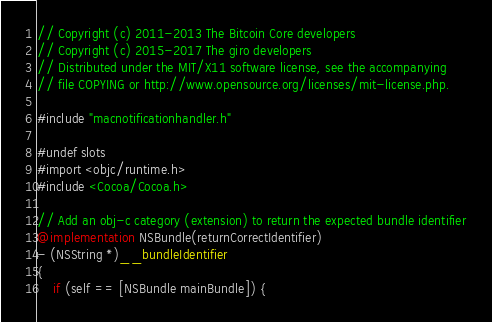Convert code to text. <code><loc_0><loc_0><loc_500><loc_500><_ObjectiveC_>// Copyright (c) 2011-2013 The Bitcoin Core developers
// Copyright (c) 2015-2017 The giro developers
// Distributed under the MIT/X11 software license, see the accompanying
// file COPYING or http://www.opensource.org/licenses/mit-license.php.

#include "macnotificationhandler.h"

#undef slots
#import <objc/runtime.h>
#include <Cocoa/Cocoa.h>

// Add an obj-c category (extension) to return the expected bundle identifier
@implementation NSBundle(returnCorrectIdentifier)
- (NSString *)__bundleIdentifier
{
    if (self == [NSBundle mainBundle]) {</code> 